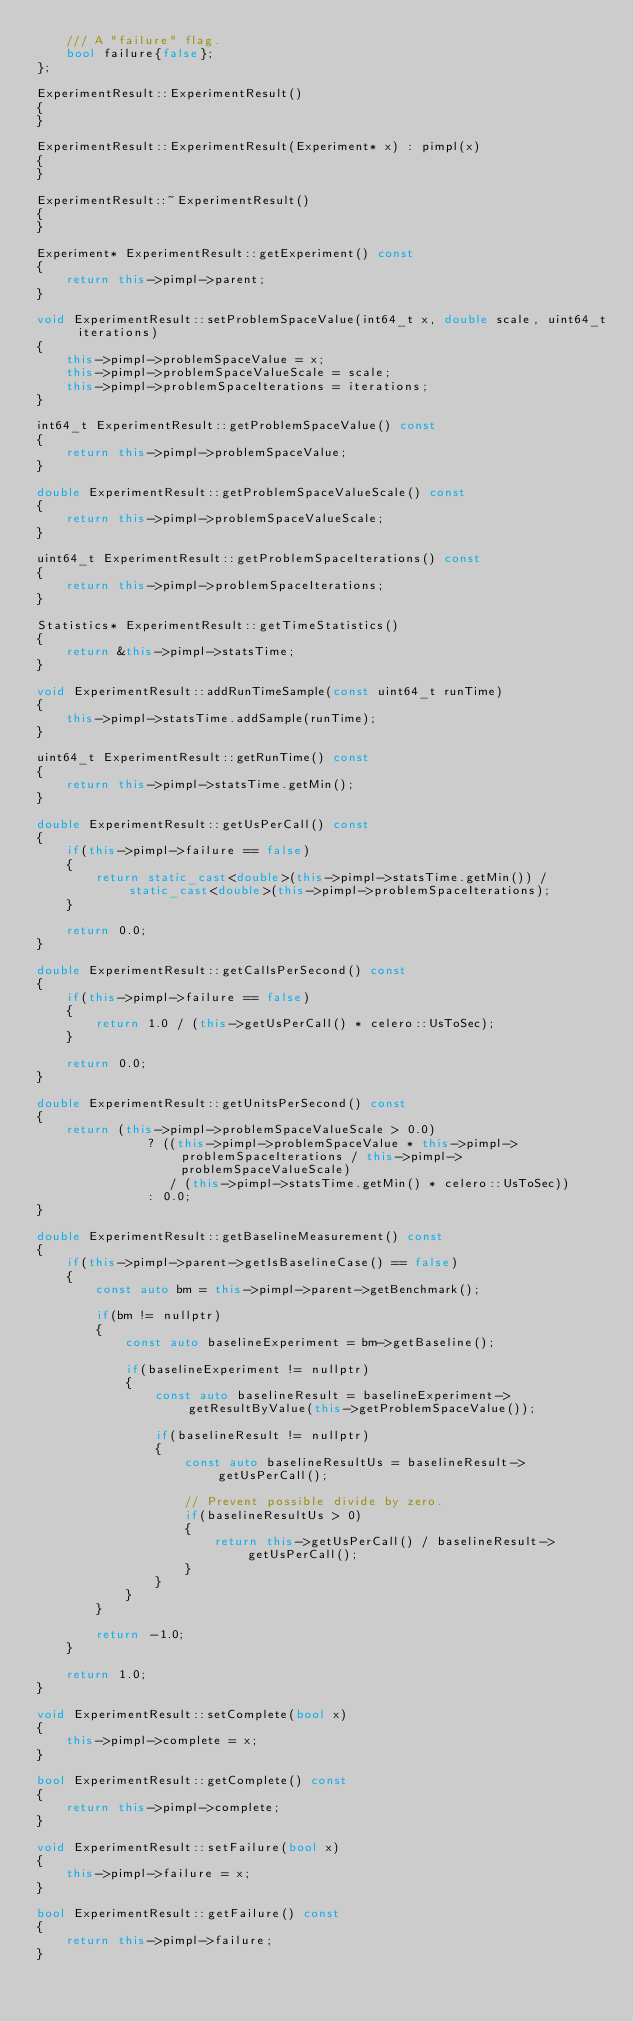Convert code to text. <code><loc_0><loc_0><loc_500><loc_500><_C++_>	/// A "failure" flag.
	bool failure{false};
};

ExperimentResult::ExperimentResult()
{
}

ExperimentResult::ExperimentResult(Experiment* x) : pimpl(x)
{
}

ExperimentResult::~ExperimentResult()
{
}

Experiment* ExperimentResult::getExperiment() const
{
	return this->pimpl->parent;
}

void ExperimentResult::setProblemSpaceValue(int64_t x, double scale, uint64_t iterations)
{
	this->pimpl->problemSpaceValue = x;
	this->pimpl->problemSpaceValueScale = scale;
	this->pimpl->problemSpaceIterations = iterations;
}

int64_t ExperimentResult::getProblemSpaceValue() const
{
	return this->pimpl->problemSpaceValue;
}

double ExperimentResult::getProblemSpaceValueScale() const
{
	return this->pimpl->problemSpaceValueScale;
}

uint64_t ExperimentResult::getProblemSpaceIterations() const
{
	return this->pimpl->problemSpaceIterations;
}

Statistics* ExperimentResult::getTimeStatistics()
{
	return &this->pimpl->statsTime;
}

void ExperimentResult::addRunTimeSample(const uint64_t runTime)
{
	this->pimpl->statsTime.addSample(runTime);
}

uint64_t ExperimentResult::getRunTime() const
{
	return this->pimpl->statsTime.getMin();
}

double ExperimentResult::getUsPerCall() const
{
	if(this->pimpl->failure == false)
	{
		return static_cast<double>(this->pimpl->statsTime.getMin()) / static_cast<double>(this->pimpl->problemSpaceIterations);
	}

	return 0.0;
}

double ExperimentResult::getCallsPerSecond() const
{
	if(this->pimpl->failure == false)
	{
		return 1.0 / (this->getUsPerCall() * celero::UsToSec);
	}

	return 0.0;
}

double ExperimentResult::getUnitsPerSecond() const
{
	return (this->pimpl->problemSpaceValueScale > 0.0)
			   ? ((this->pimpl->problemSpaceValue * this->pimpl->problemSpaceIterations / this->pimpl->problemSpaceValueScale)
				  / (this->pimpl->statsTime.getMin() * celero::UsToSec))
			   : 0.0;
}

double ExperimentResult::getBaselineMeasurement() const
{
	if(this->pimpl->parent->getIsBaselineCase() == false)
	{
		const auto bm = this->pimpl->parent->getBenchmark();

		if(bm != nullptr)
		{
			const auto baselineExperiment = bm->getBaseline();

			if(baselineExperiment != nullptr)
			{
				const auto baselineResult = baselineExperiment->getResultByValue(this->getProblemSpaceValue());

				if(baselineResult != nullptr)
				{
					const auto baselineResultUs = baselineResult->getUsPerCall();

					// Prevent possible divide by zero.
					if(baselineResultUs > 0)
					{
						return this->getUsPerCall() / baselineResult->getUsPerCall();
					}
				}
			}
		}

		return -1.0;
	}

	return 1.0;
}

void ExperimentResult::setComplete(bool x)
{
	this->pimpl->complete = x;
}

bool ExperimentResult::getComplete() const
{
	return this->pimpl->complete;
}

void ExperimentResult::setFailure(bool x)
{
	this->pimpl->failure = x;
}

bool ExperimentResult::getFailure() const
{
	return this->pimpl->failure;
}
</code> 